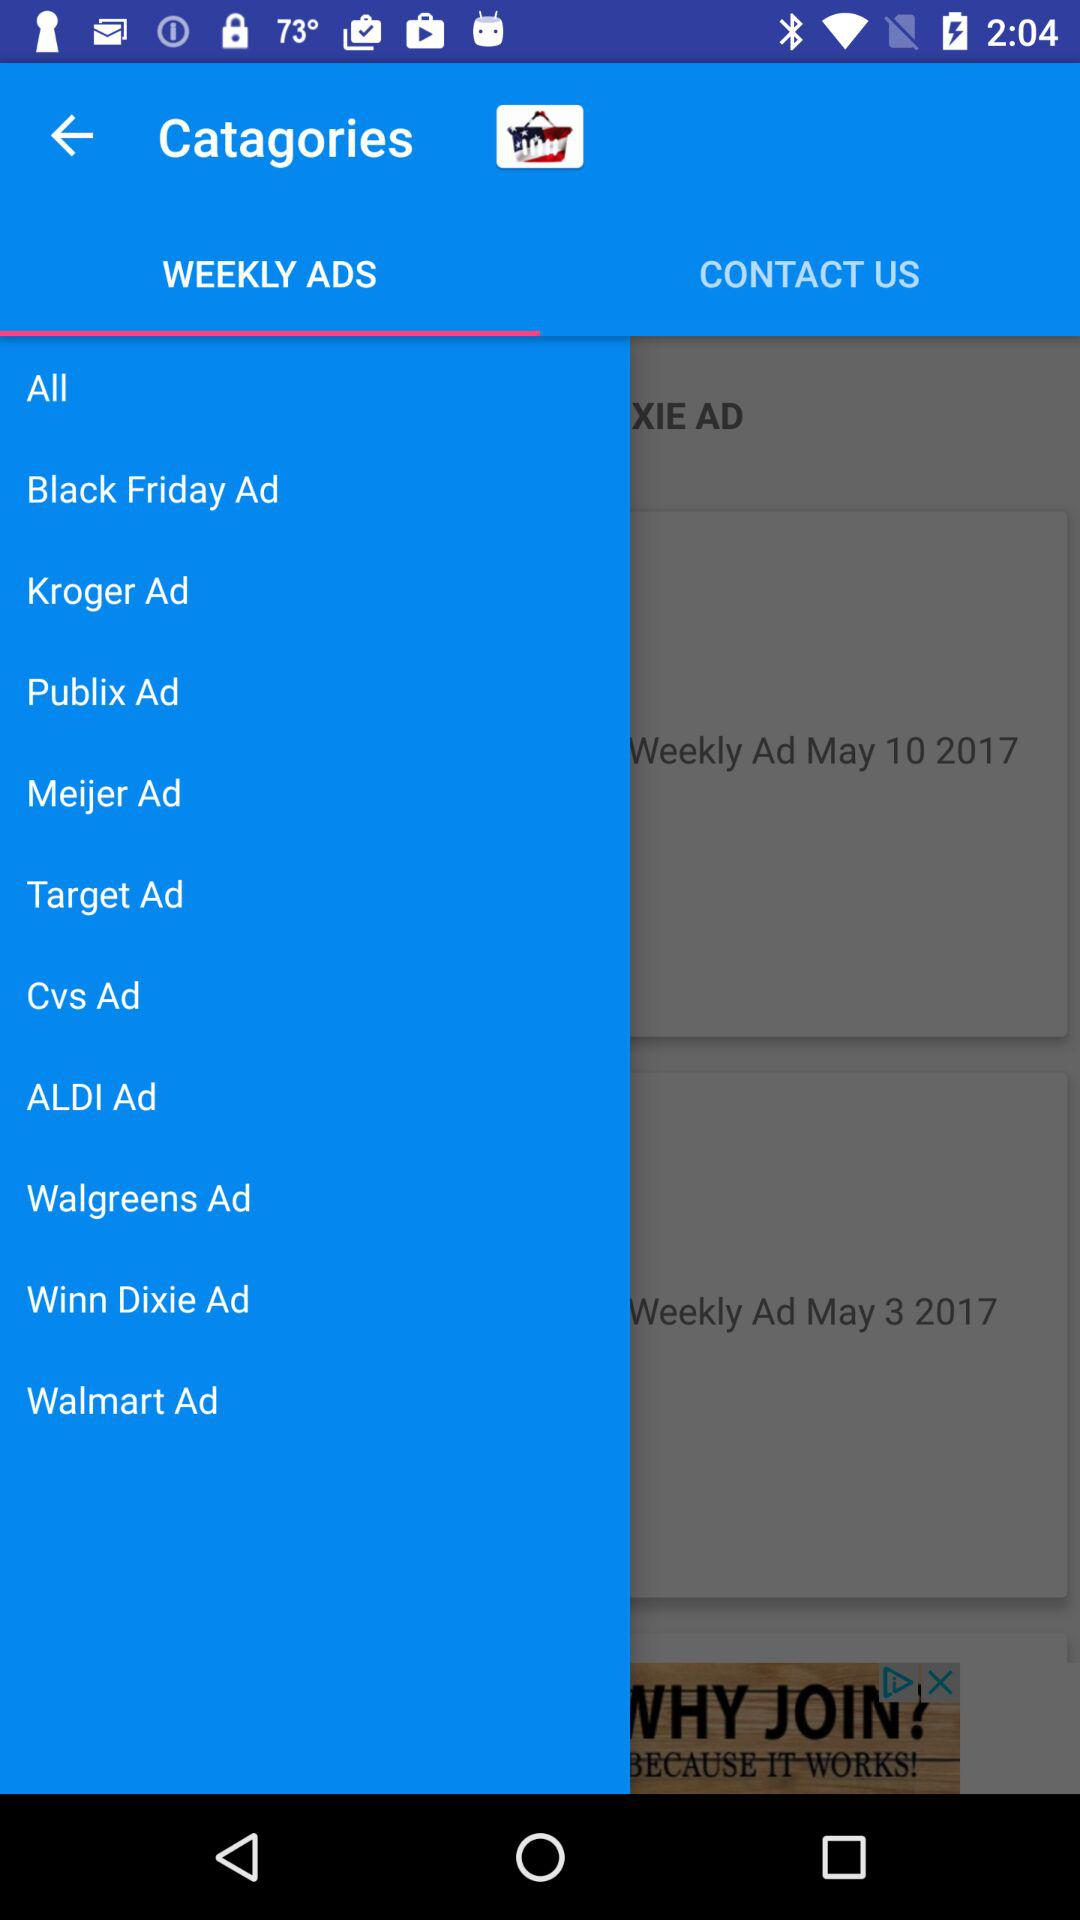How many ads are there in total?
Answer the question using a single word or phrase. 10 